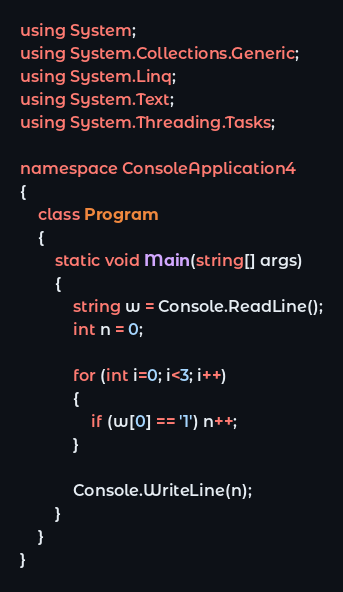<code> <loc_0><loc_0><loc_500><loc_500><_C#_>using System;
using System.Collections.Generic;
using System.Linq;
using System.Text;
using System.Threading.Tasks;

namespace ConsoleApplication4
{
    class Program
    {
        static void Main(string[] args)
        {
            string w = Console.ReadLine();
            int n = 0;

            for (int i=0; i<3; i++)
            {
                if (w[0] == '1') n++;
            }

            Console.WriteLine(n);
        }
    }
}</code> 